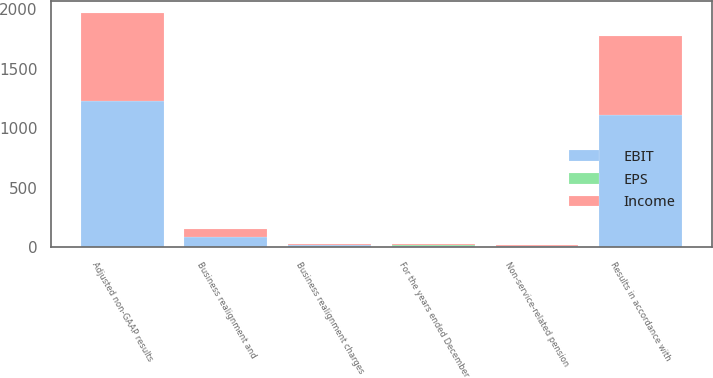<chart> <loc_0><loc_0><loc_500><loc_500><stacked_bar_chart><ecel><fcel>Results in accordance with<fcel>Business realignment charges<fcel>Non-service-related pension<fcel>Adjusted non-GAAP results<fcel>For the years ended December<fcel>Business realignment and<nl><fcel>EBIT<fcel>1111.1<fcel>13.7<fcel>12<fcel>1228.9<fcel>8.4<fcel>83.4<nl><fcel>Income<fcel>660.9<fcel>8.4<fcel>7.4<fcel>740<fcel>8.4<fcel>68.6<nl><fcel>EPS<fcel>2.89<fcel>0.04<fcel>0.03<fcel>3.24<fcel>8.4<fcel>0.3<nl></chart> 